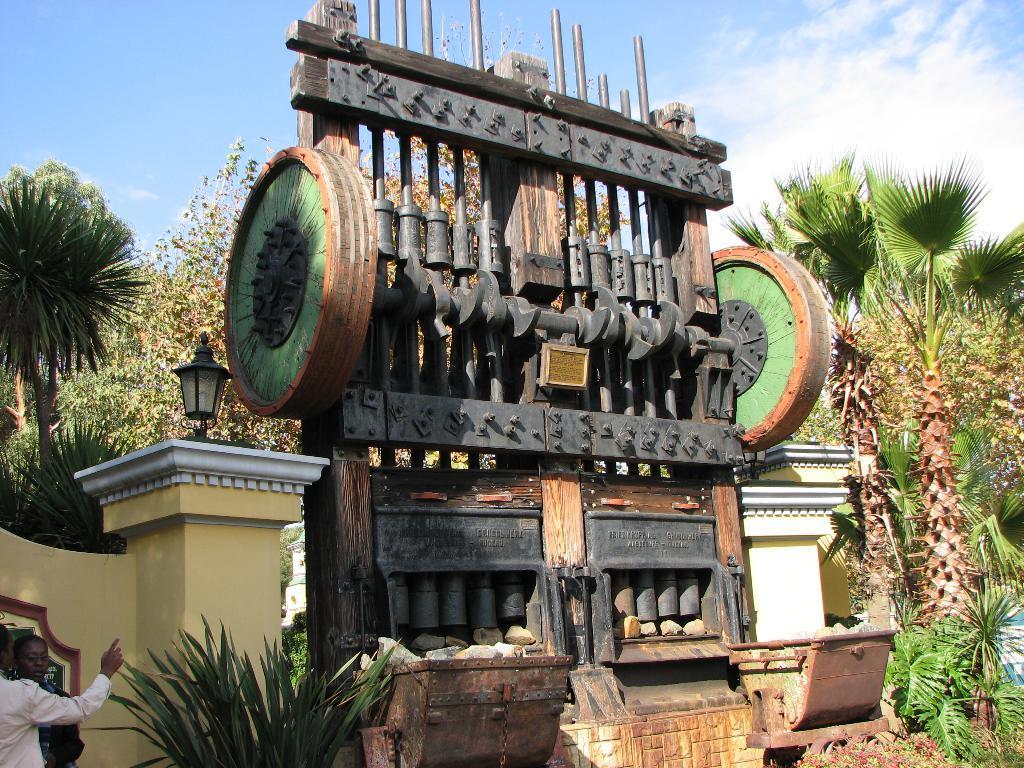How would you summarize this image in a sentence or two? In this image we can see two persons standing near the wall, here we can see the plants, lamp on the wall, different kind of the wall design, trees and the sky with clouds in the background. 